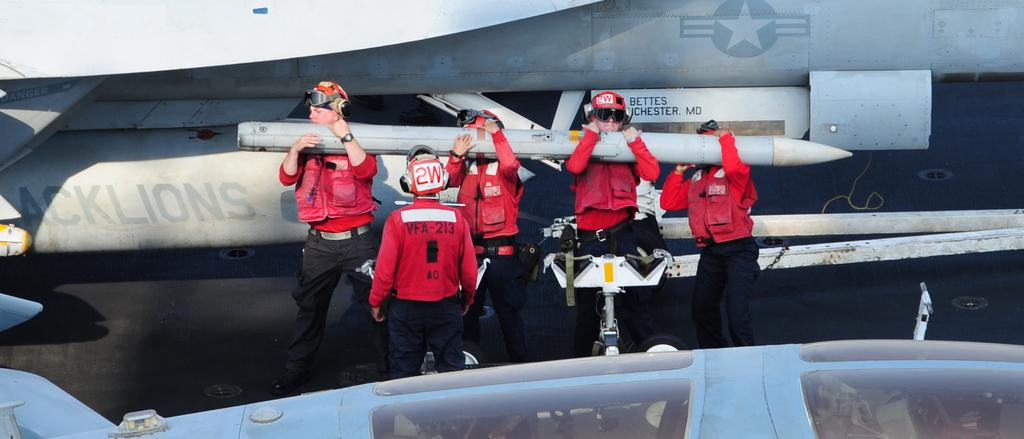Who or what is present in the image? There are people in the image. What are the people doing in the image? The people are standing and holding a missile. What can be seen in the background of the image? There are aeroplanes in the background of the image. What is visible at the bottom of the image? There is a runway visible at the bottom of the image. What type of muscle is being flexed by the people in the image? There is no indication in the image that the people are flexing any muscles; they are holding a missile. 